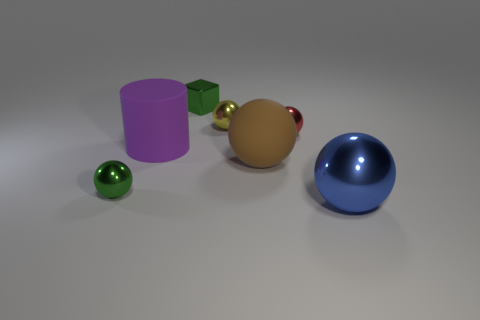Subtract 2 spheres. How many spheres are left? 3 Subtract all green balls. How many balls are left? 4 Subtract all brown balls. How many balls are left? 4 Subtract all brown balls. Subtract all cyan cylinders. How many balls are left? 4 Add 2 small blue rubber cylinders. How many objects exist? 9 Subtract all spheres. How many objects are left? 2 Subtract 1 purple cylinders. How many objects are left? 6 Subtract all blue spheres. Subtract all large rubber objects. How many objects are left? 4 Add 5 blue metallic balls. How many blue metallic balls are left? 6 Add 2 blue things. How many blue things exist? 3 